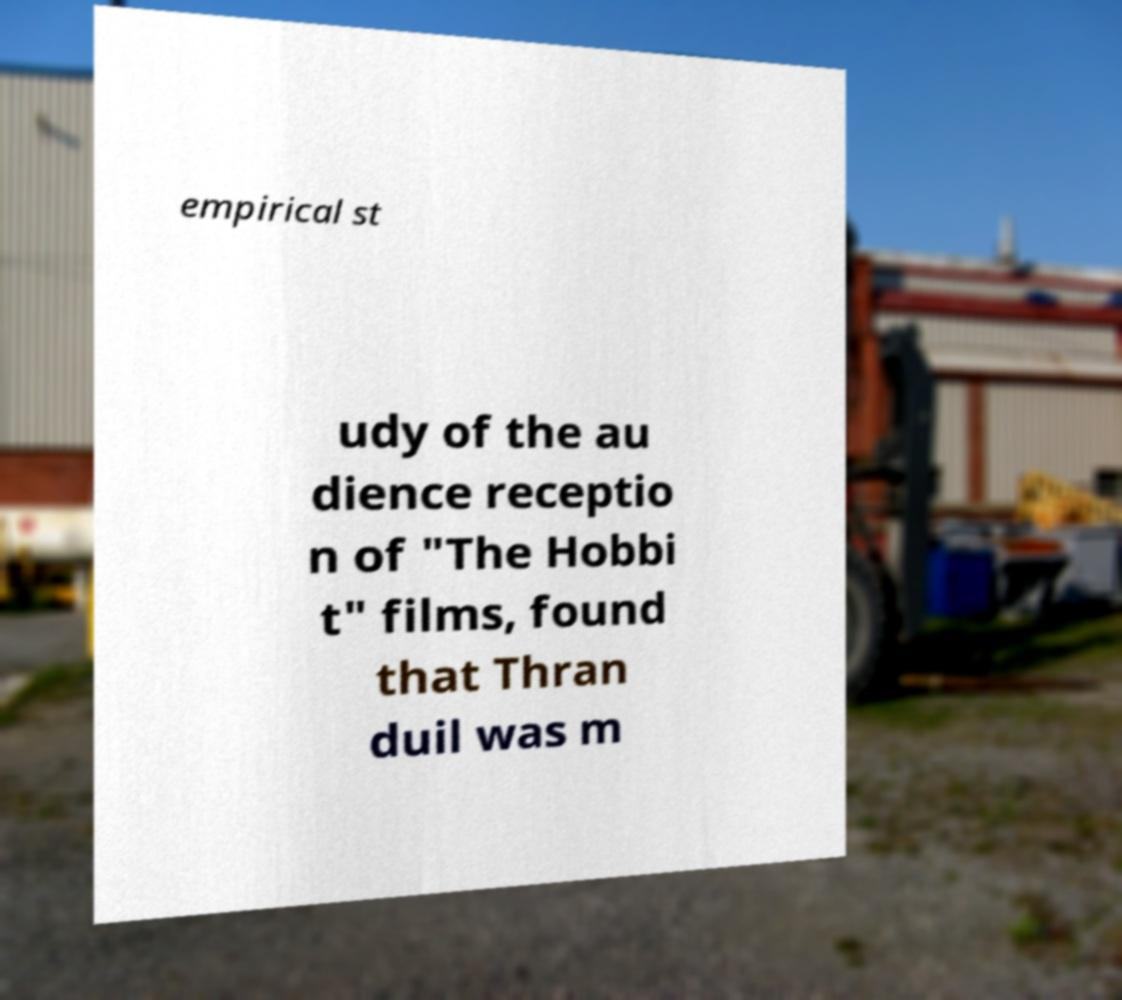I need the written content from this picture converted into text. Can you do that? empirical st udy of the au dience receptio n of "The Hobbi t" films, found that Thran duil was m 